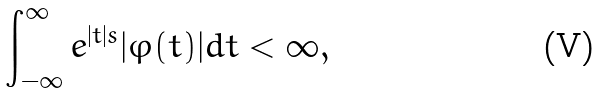<formula> <loc_0><loc_0><loc_500><loc_500>\int _ { - \infty } ^ { \infty } e ^ { | t | s } | \varphi ( t ) | d t < \infty ,</formula> 